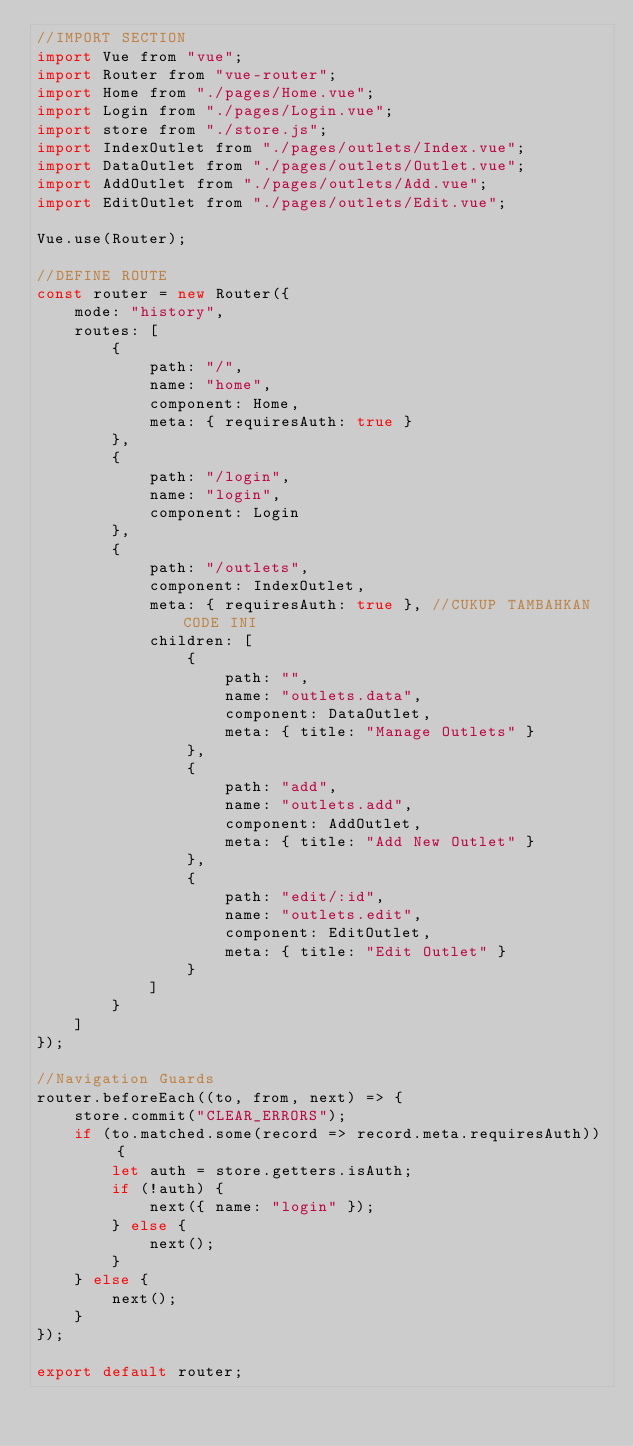<code> <loc_0><loc_0><loc_500><loc_500><_JavaScript_>//IMPORT SECTION
import Vue from "vue";
import Router from "vue-router";
import Home from "./pages/Home.vue";
import Login from "./pages/Login.vue";
import store from "./store.js";
import IndexOutlet from "./pages/outlets/Index.vue";
import DataOutlet from "./pages/outlets/Outlet.vue";
import AddOutlet from "./pages/outlets/Add.vue";
import EditOutlet from "./pages/outlets/Edit.vue";

Vue.use(Router);

//DEFINE ROUTE
const router = new Router({
    mode: "history",
    routes: [
        {
            path: "/",
            name: "home",
            component: Home,
            meta: { requiresAuth: true }
        },
        {
            path: "/login",
            name: "login",
            component: Login
        },
        {
            path: "/outlets",
            component: IndexOutlet,
            meta: { requiresAuth: true }, //CUKUP TAMBAHKAN CODE INI
            children: [
                {
                    path: "",
                    name: "outlets.data",
                    component: DataOutlet,
                    meta: { title: "Manage Outlets" }
                },
                {
                    path: "add",
                    name: "outlets.add",
                    component: AddOutlet,
                    meta: { title: "Add New Outlet" }
                },
                {
                    path: "edit/:id",
                    name: "outlets.edit",
                    component: EditOutlet,
                    meta: { title: "Edit Outlet" }
                }
            ]
        }
    ]
});

//Navigation Guards
router.beforeEach((to, from, next) => {
    store.commit("CLEAR_ERRORS");
    if (to.matched.some(record => record.meta.requiresAuth)) {
        let auth = store.getters.isAuth;
        if (!auth) {
            next({ name: "login" });
        } else {
            next();
        }
    } else {
        next();
    }
});

export default router;
</code> 